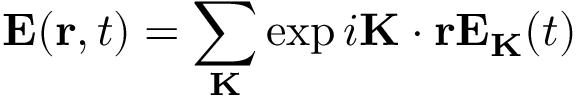Convert formula to latex. <formula><loc_0><loc_0><loc_500><loc_500>E ( r , t ) = \sum _ { K } \exp { i K \cdot r } E _ { K } ( t )</formula> 